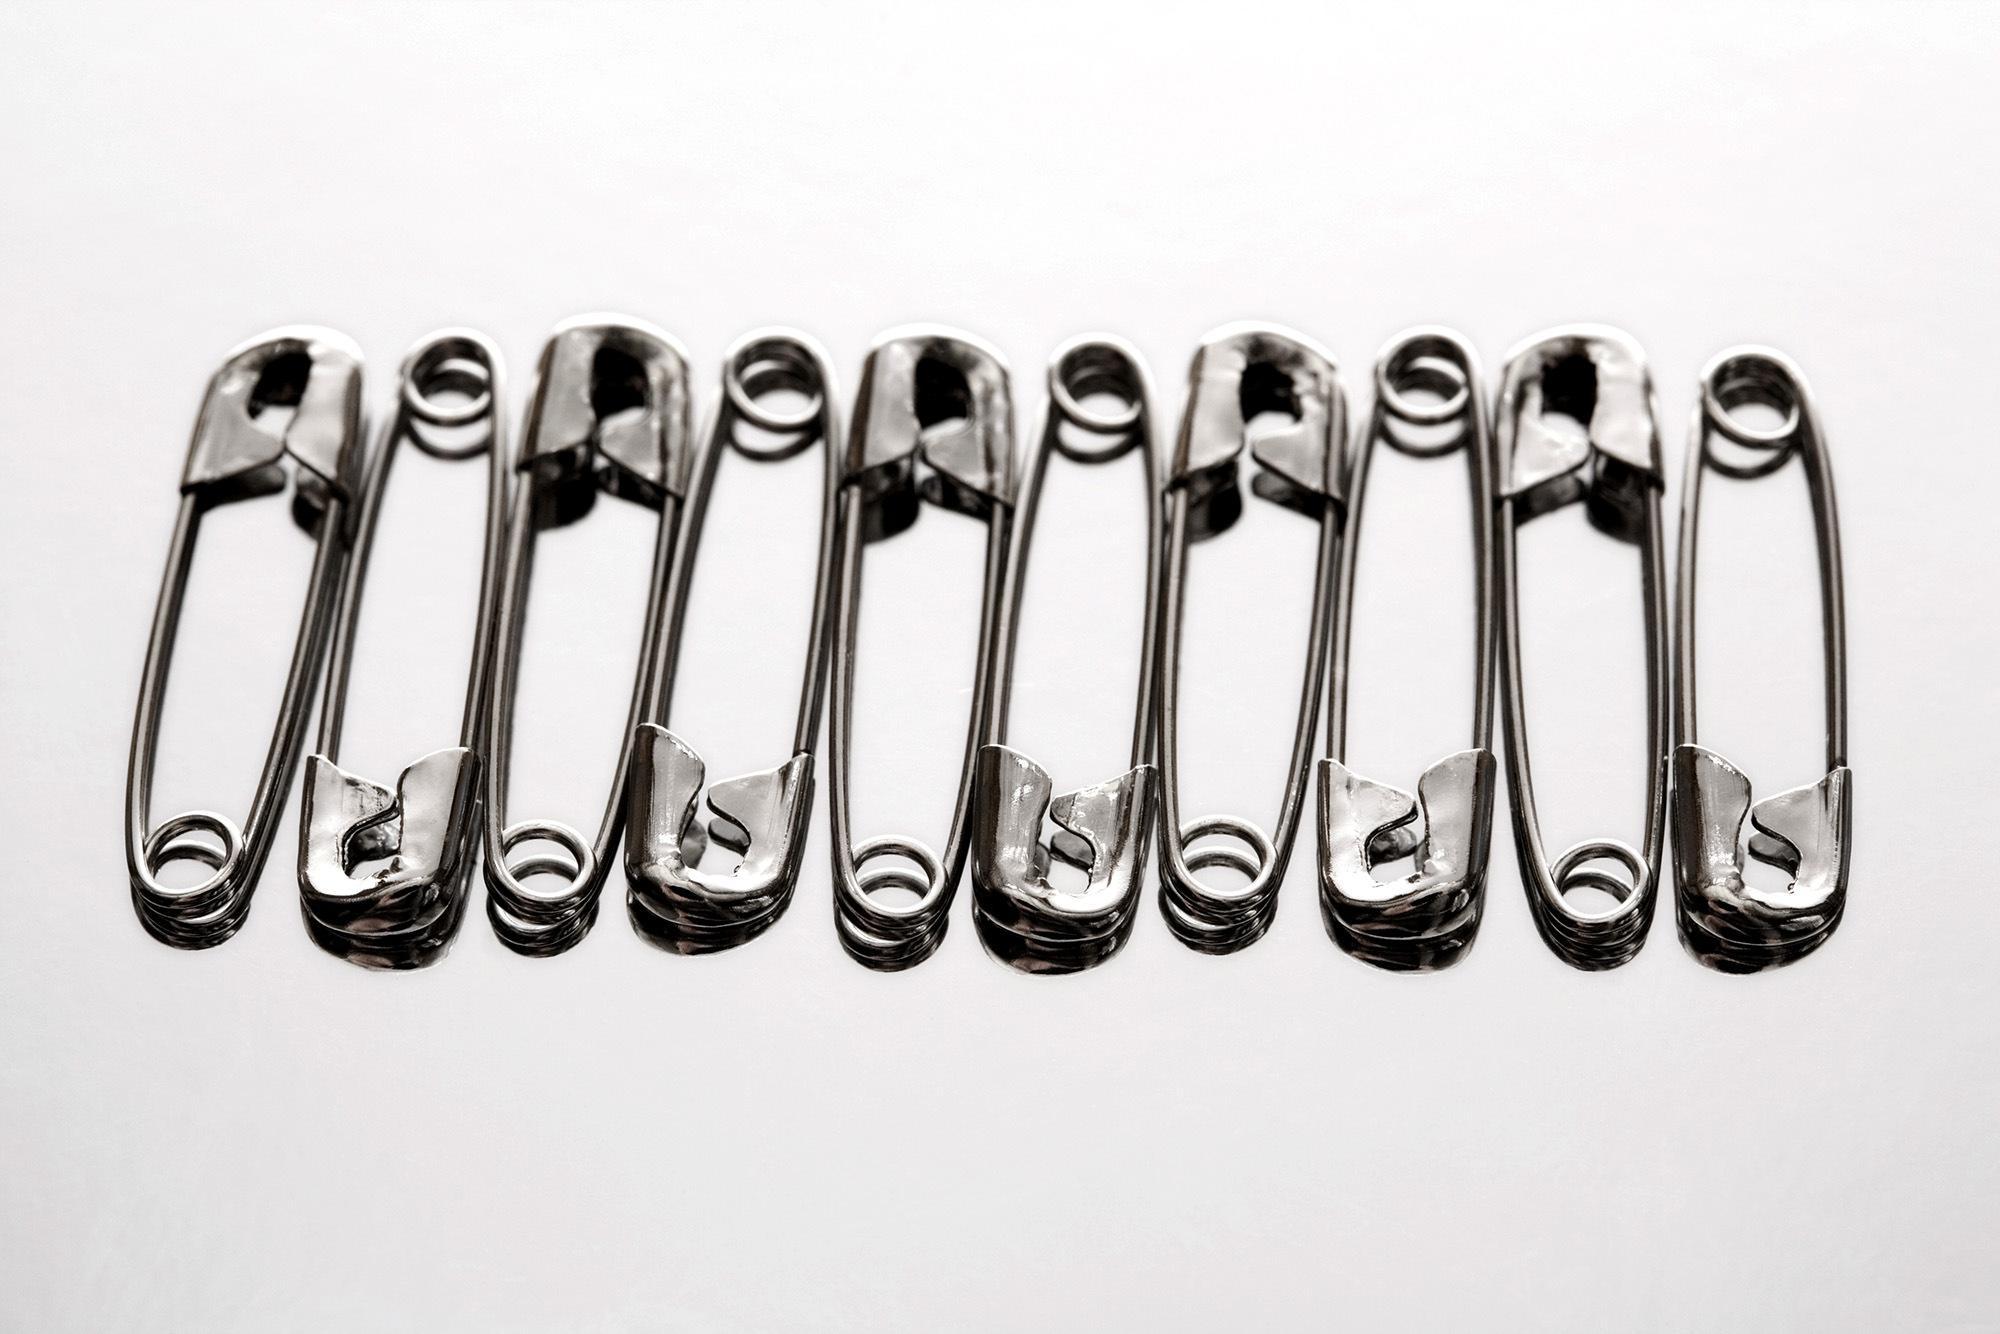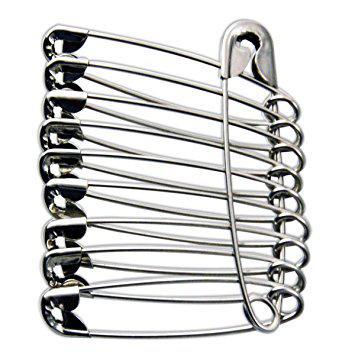The first image is the image on the left, the second image is the image on the right. Assess this claim about the two images: "An image shows one row of at least 10 unlinked safety pins.". Correct or not? Answer yes or no. Yes. The first image is the image on the left, the second image is the image on the right. Given the left and right images, does the statement "In one image, safety pins are arranged from small to large and back to small sizes." hold true? Answer yes or no. No. 